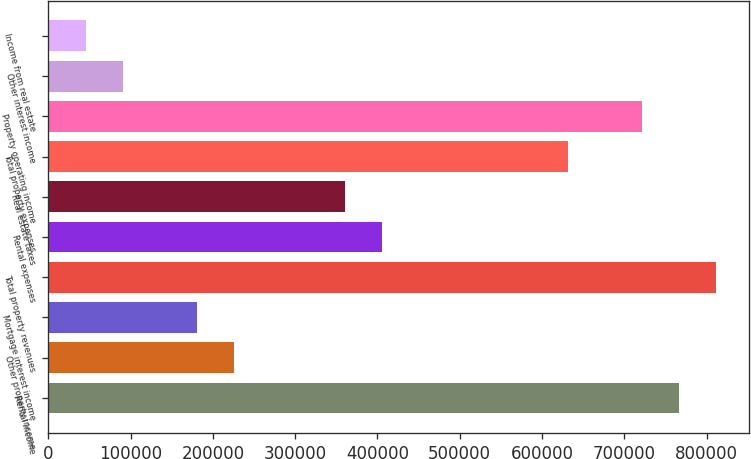Convert chart. <chart><loc_0><loc_0><loc_500><loc_500><bar_chart><fcel>Rental income<fcel>Other property income<fcel>Mortgage interest income<fcel>Total property revenues<fcel>Rental expenses<fcel>Real estate taxes<fcel>Total property expenses<fcel>Property operating income<fcel>Other interest income<fcel>Income from real estate<nl><fcel>766513<fcel>225671<fcel>180601<fcel>811584<fcel>405952<fcel>360882<fcel>631303<fcel>721443<fcel>90460.4<fcel>45390.2<nl></chart> 